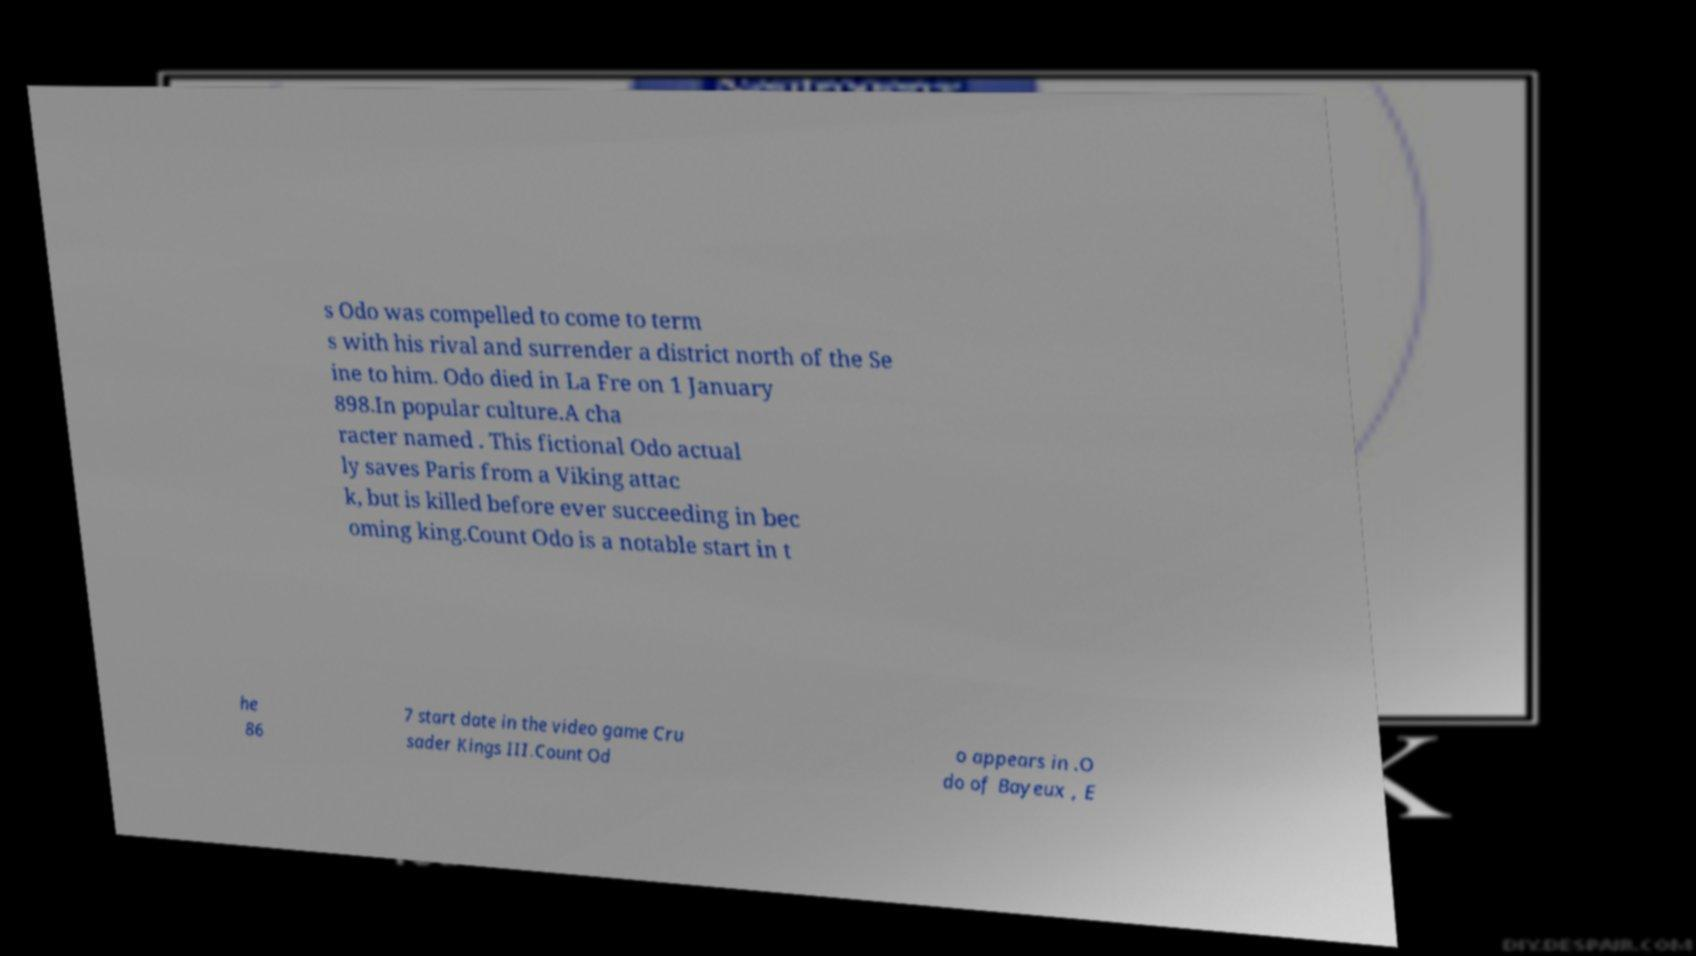For documentation purposes, I need the text within this image transcribed. Could you provide that? s Odo was compelled to come to term s with his rival and surrender a district north of the Se ine to him. Odo died in La Fre on 1 January 898.In popular culture.A cha racter named . This fictional Odo actual ly saves Paris from a Viking attac k, but is killed before ever succeeding in bec oming king.Count Odo is a notable start in t he 86 7 start date in the video game Cru sader Kings III.Count Od o appears in .O do of Bayeux , E 